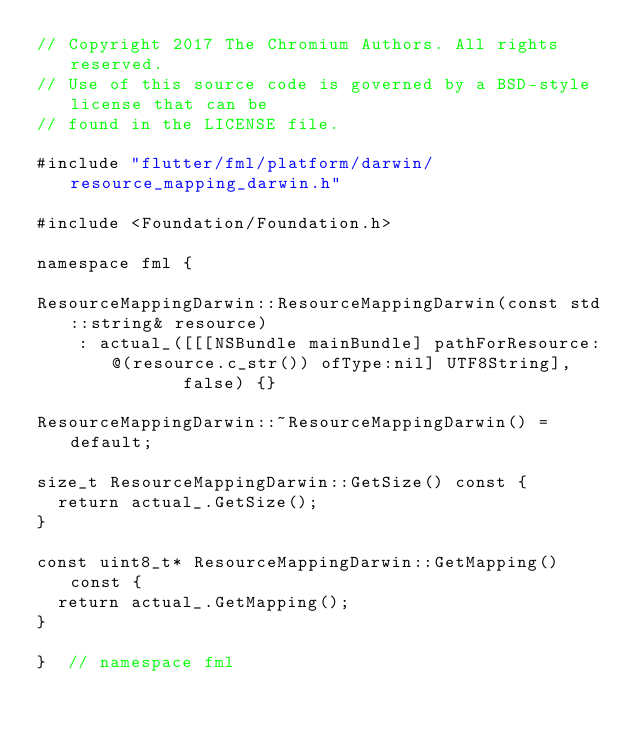Convert code to text. <code><loc_0><loc_0><loc_500><loc_500><_ObjectiveC_>// Copyright 2017 The Chromium Authors. All rights reserved.
// Use of this source code is governed by a BSD-style license that can be
// found in the LICENSE file.

#include "flutter/fml/platform/darwin/resource_mapping_darwin.h"

#include <Foundation/Foundation.h>

namespace fml {

ResourceMappingDarwin::ResourceMappingDarwin(const std::string& resource)
    : actual_([[[NSBundle mainBundle] pathForResource:@(resource.c_str()) ofType:nil] UTF8String],
              false) {}

ResourceMappingDarwin::~ResourceMappingDarwin() = default;

size_t ResourceMappingDarwin::GetSize() const {
  return actual_.GetSize();
}

const uint8_t* ResourceMappingDarwin::GetMapping() const {
  return actual_.GetMapping();
}

}  // namespace fml
</code> 